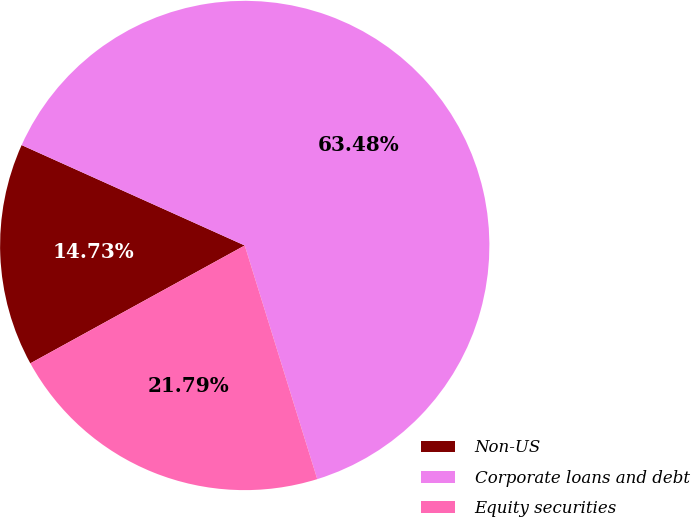Convert chart to OTSL. <chart><loc_0><loc_0><loc_500><loc_500><pie_chart><fcel>Non-US<fcel>Corporate loans and debt<fcel>Equity securities<nl><fcel>14.73%<fcel>63.48%<fcel>21.79%<nl></chart> 